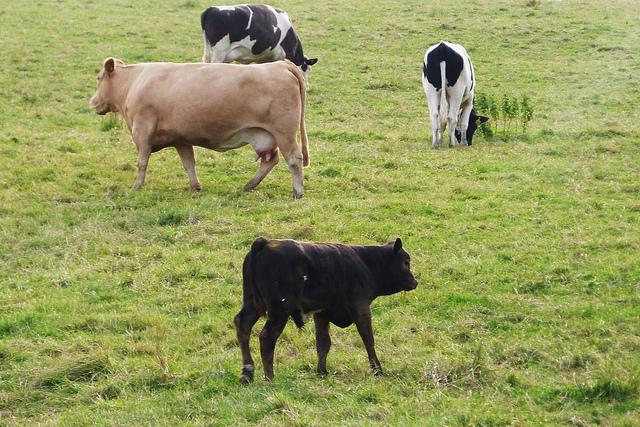What color is the cow?
Be succinct. Black. Are the cows penned up?
Give a very brief answer. No. How many white cows appear in the photograph?
Keep it brief. 2. Are the cows all looking at the camera?
Write a very short answer. No. What color are the cows?
Keep it brief. Different colors. How many animals are eating?
Write a very short answer. 2. Which cow is smaller?
Write a very short answer. Black. How which colored cow is the biggest?
Concise answer only. Tan. Does the black cow weigh more than 200 pounds?
Concise answer only. Yes. What color is the grass?
Concise answer only. Green. How many animals are in the picture?
Be succinct. 4. 